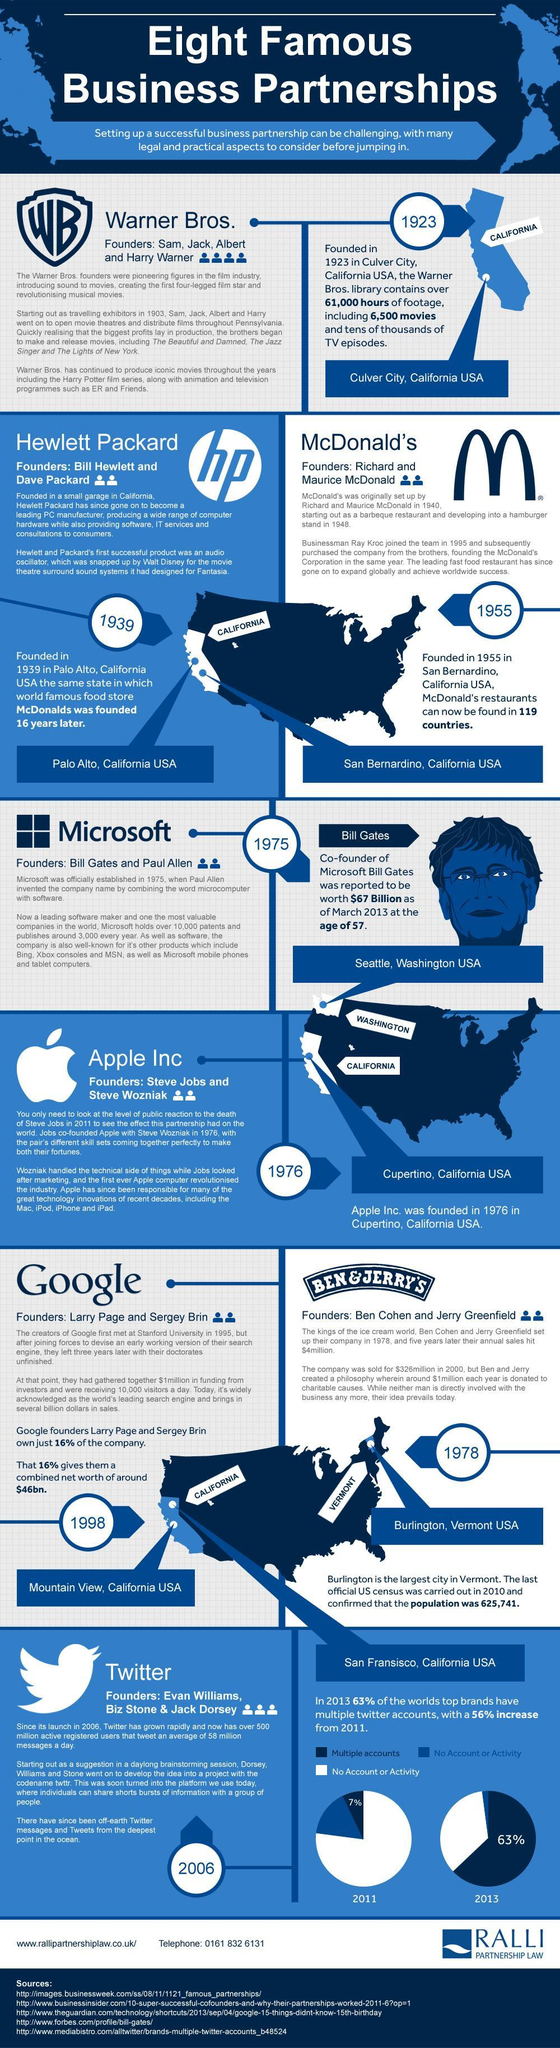How many founders did Apple Inc. have?
Answer the question with a short phrase. 2 where was Ben and Jerry's founded? Burlington, Vermont USA How many years after McDonald's was Microsoft founded? 20 How many years before Google was Ben and Jerry's founded? 20 How many founders did Hewlett Packard have? 2 How many founders did Google have? 2 Where was Google founded? Mountain View, California USA What percentage of top brands had No account or activity in twitter in 2011? 93% What percentage of top brands had multiple twitter accounts in 2011? 7% How many years after Microsoft was Apple Inc. founded? 1 In which state was Hewlett Packard and McDonald's founded? California How many founders did Warner Bros. have? 4 